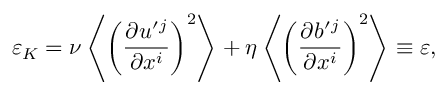<formula> <loc_0><loc_0><loc_500><loc_500>\varepsilon _ { K } = \nu \left \langle { \left ( { \frac { \partial u ^ { \prime ^ { j } } { \partial x ^ { i } } } \right ) ^ { 2 } } \right \rangle + \eta \left \langle { \left ( { \frac { \partial b ^ { \prime ^ { j } } { \partial x ^ { i } } } \right ) ^ { 2 } } \right \rangle \equiv \varepsilon ,</formula> 